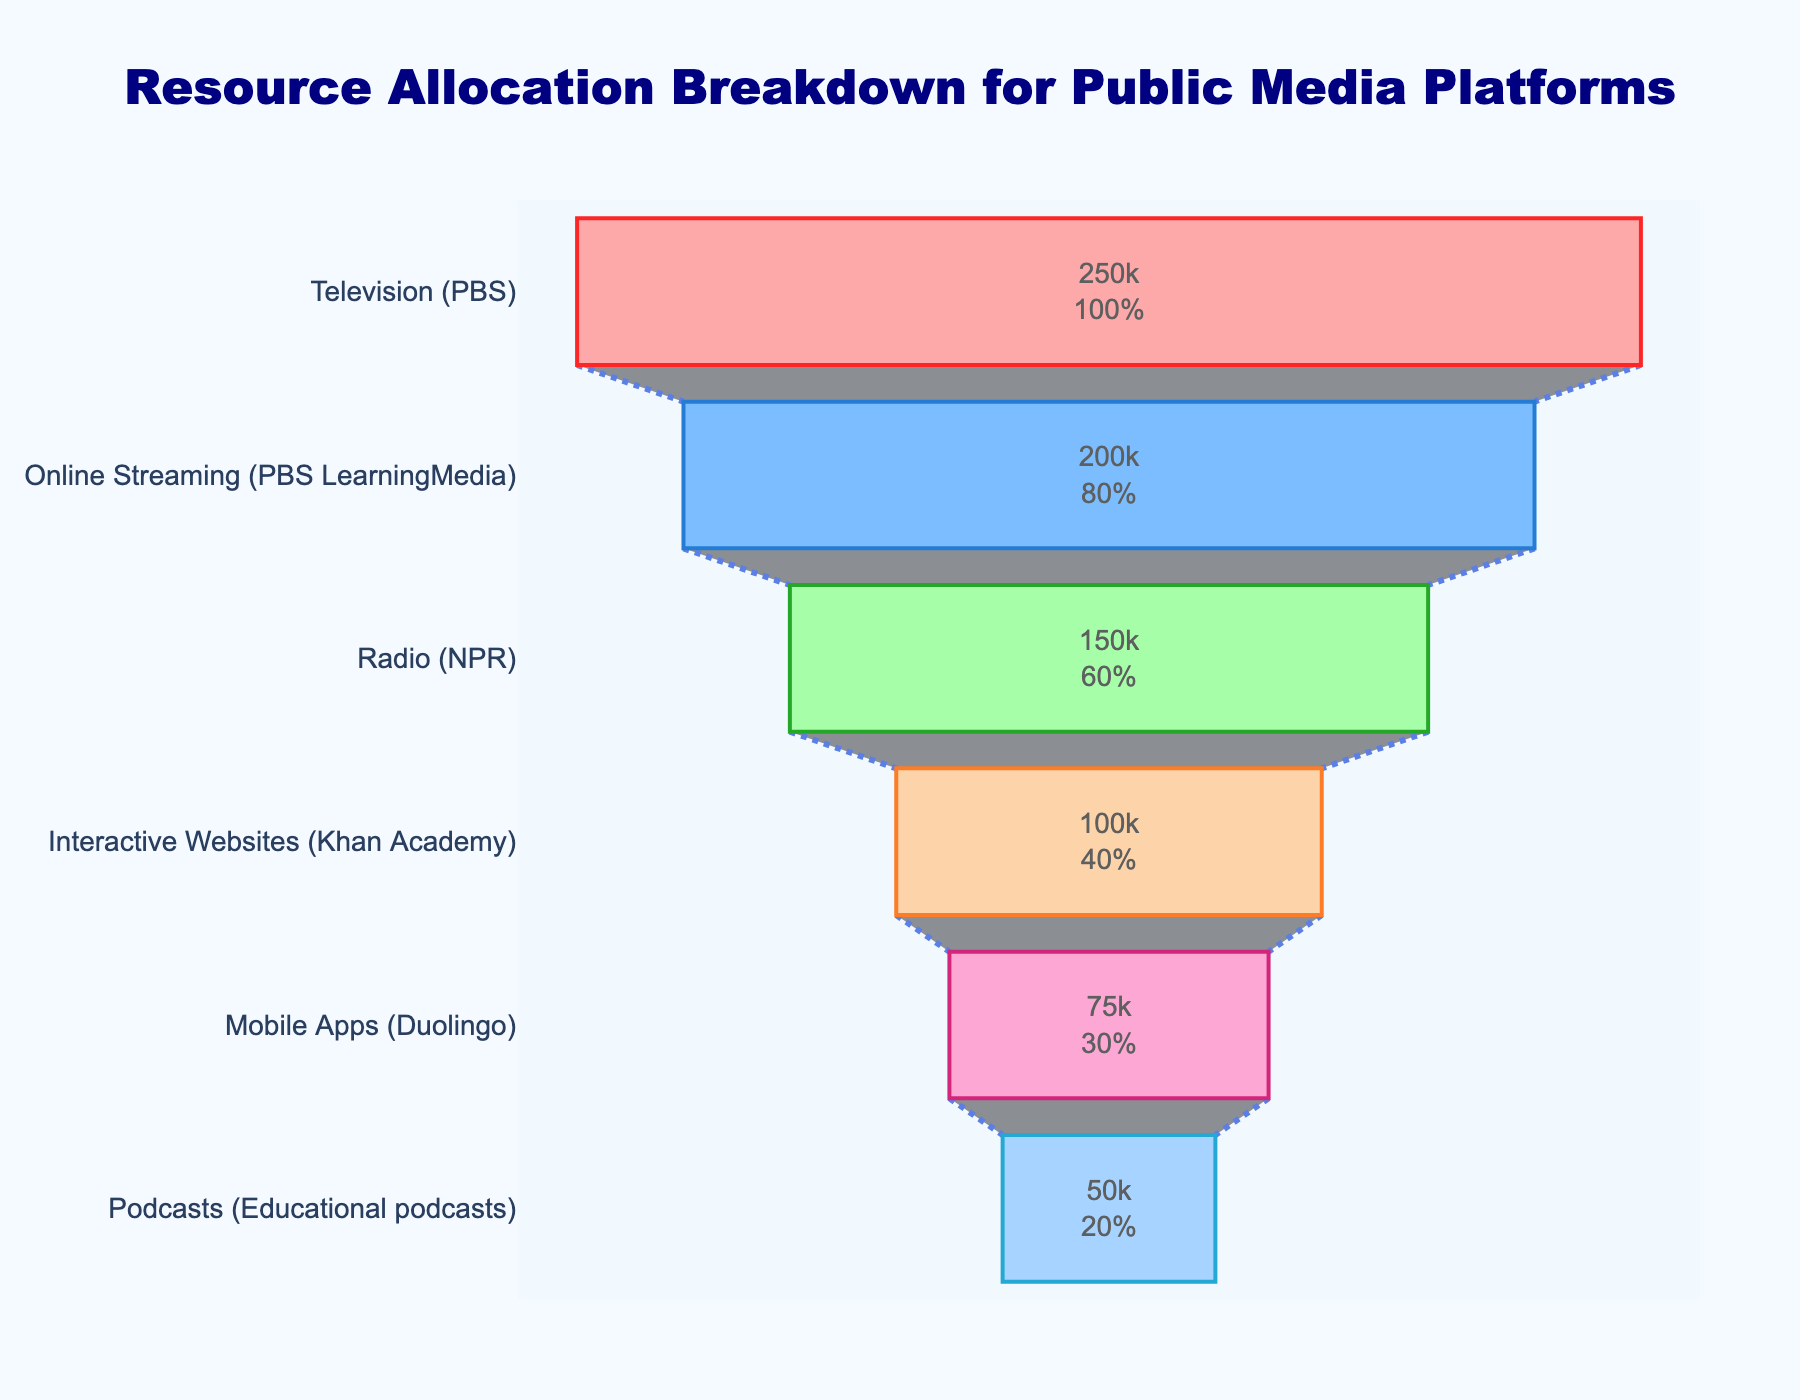What is the title of the funnel chart? The chart's title is written prominently at the top and usually indicates what the chart is about. Here, it is clearly visible and reads “Resource Allocation Breakdown for Public Media Platforms.”
Answer: Resource Allocation Breakdown for Public Media Platforms Which platform has the highest budget allocation? Looking at the funnel, the widest section will represent the platform with the highest budget allocation. In this case, it is the top segment labeled "Television (PBS)" with $250,000.
Answer: Television (PBS) How does the budget allocation for Mobile Apps (Duolingo) compare to that of Podcasts (Educational podcasts)? By looking at the funnel, we see that each segment represents a budget allocation for different platforms. The segment for Mobile Apps (Duolingo) shows $75,000 while Podcasts (Educational podcasts) have $50,000.
Answer: Mobile Apps (Duolingo) have a higher budget allocation than Podcasts (Educational podcasts) What percentage of the initial total budget is allocated to Online Streaming (PBS LearningMedia)? The second segment from the top is Online Streaming (PBS LearningMedia), this segment displays both the value and percentage of the initial budget. The segment shows $200,000 and the percentage of the initial total budget allocated to this is listed in the segment itself.
Answer: 20% What is the combined budget allocation for Radio (NPR) and Interactive Websites (Khan Academy)? To find the combined budget allocation, we add the individual values for both platforms. From the funnel chart, Radio (NPR) has $150,000 and Interactive Websites (Khan Academy) has $100,000. So, $150,000 + $100,000 = $250,000.
Answer: $250,000 Which platform has the second lowest budget allocation? Ascending from the bottom of the funnel, the second segment represents the second lowest allocation. This segment is for Mobile Apps (Duolingo) and shows a budget allocation of $75,000.
Answer: Mobile Apps (Duolingo) How much more budget is allocated to Television (PBS) compared to Radio (NPR)? By determining the budget amounts from the funnel segments for both platforms, Television (PBS) has $250,000 and Radio (NPR) has $150,000. Subtracting these gives $250,000 - $150,000 = $100,000.
Answer: $100,000 What is the smallest percentage of the initial budget allocated to a single platform, and which platform is it? The smallest segment in the funnel represents the lowest percentage of the budget. The bottom-most segment, Podcasts (Educational podcasts), shows both the budget ($50,000) and the smallest percentage of the initial budget.
Answer: 5%, Podcasts (Educational podcasts) What fraction of the total budget is allocated to Online Streaming (PBS LearningMedia) and Interactive Websites (Khan Academy) combined? Adding the budgets of Online Streaming ($200,000) and Interactive Websites ($100,000) results in $300,000. The total initial budget is the sum of all allocations: $250,000 + $200,000 + $150,000 + $100,000 + $75,000 + $50,000 = $825,000. Therefore, the fraction is $300,000 / $825,000.
Answer: 300,000/825,000 = 0.3636 How does the allocation for Interactive Websites (Khan Academy) compare with that for Online Streaming (PBS LearningMedia)? Examining their positions in the funnel, Interactive Websites (Khan Academy) is represented by a smaller segment compared to Online Streaming (PBS LearningMedia). The amounts $100,000 and $200,000 respectively indicate a smaller budget for Interactive Websites.
Answer: Interactive Websites (Khan Academy) has a lower budget allocation than Online Streaming (PBS LearningMedia) 